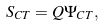Convert formula to latex. <formula><loc_0><loc_0><loc_500><loc_500>S _ { C T } = Q \Psi _ { C T } ,</formula> 